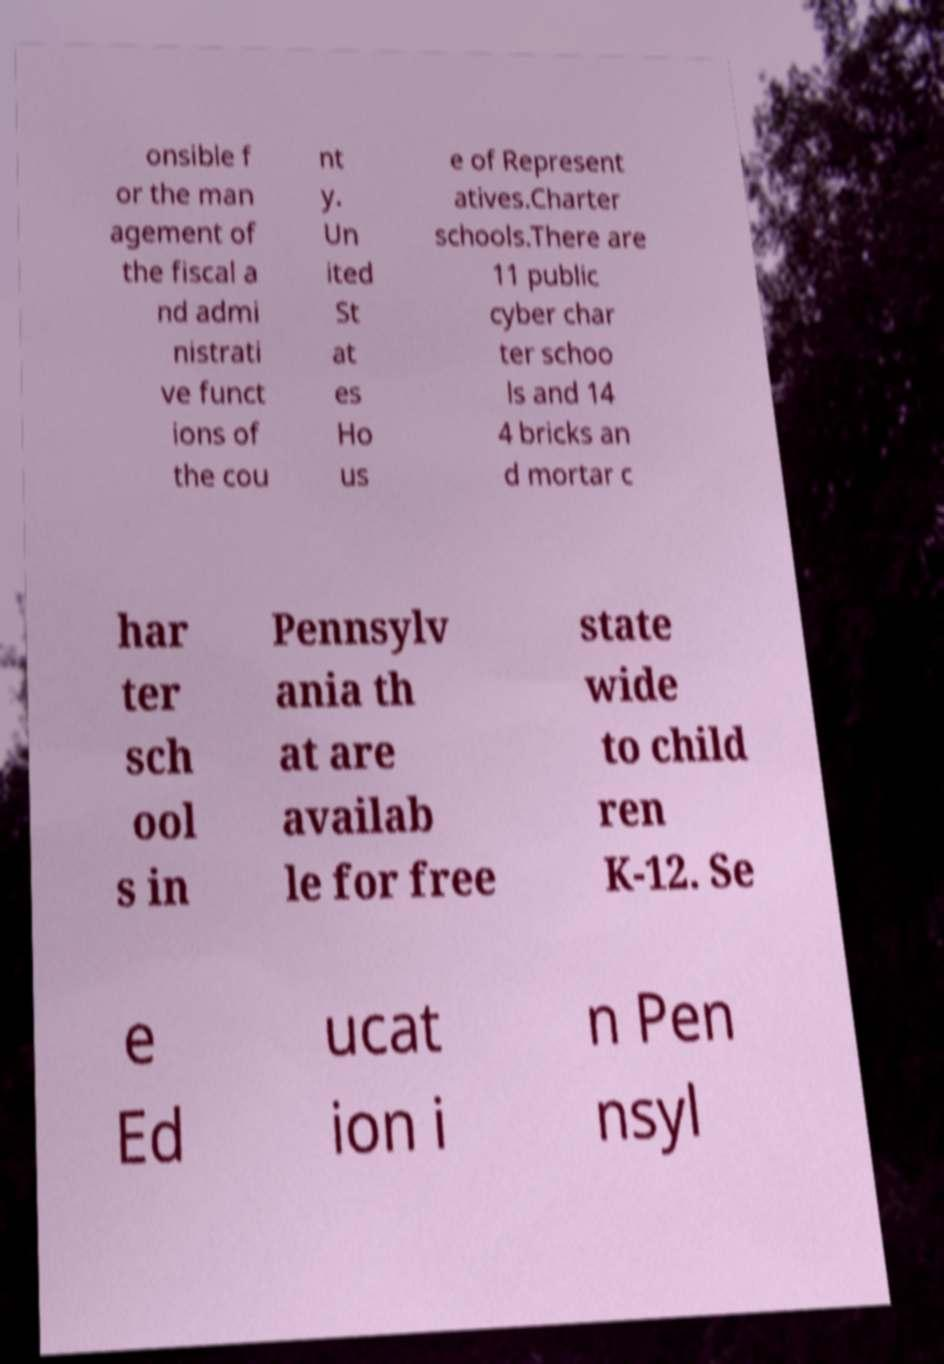Can you accurately transcribe the text from the provided image for me? onsible f or the man agement of the fiscal a nd admi nistrati ve funct ions of the cou nt y. Un ited St at es Ho us e of Represent atives.Charter schools.There are 11 public cyber char ter schoo ls and 14 4 bricks an d mortar c har ter sch ool s in Pennsylv ania th at are availab le for free state wide to child ren K-12. Se e Ed ucat ion i n Pen nsyl 